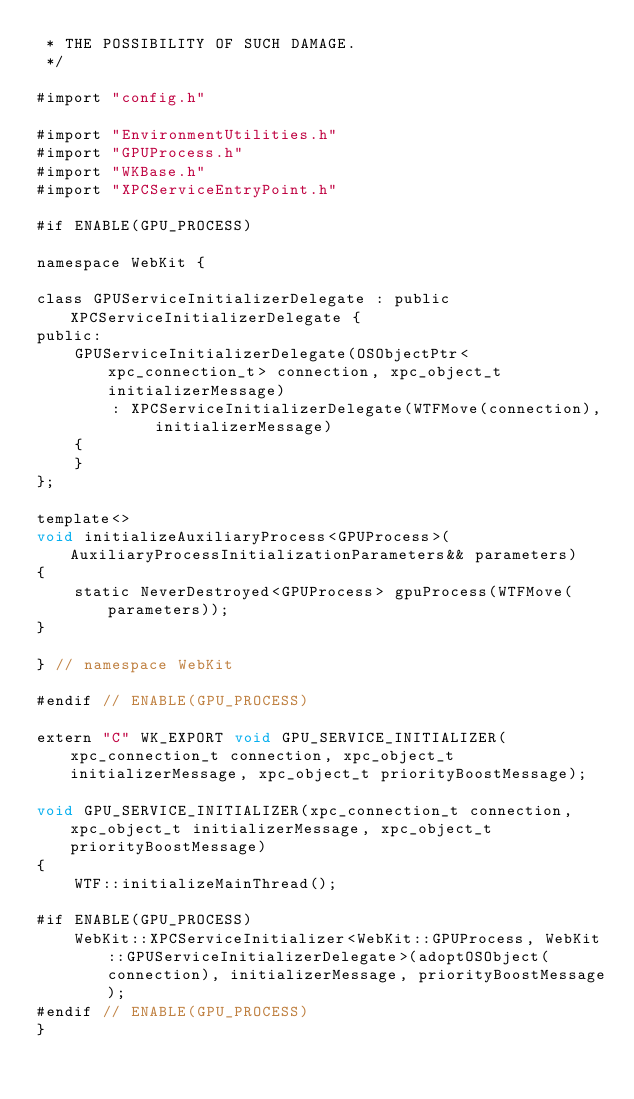<code> <loc_0><loc_0><loc_500><loc_500><_ObjectiveC_> * THE POSSIBILITY OF SUCH DAMAGE.
 */

#import "config.h"

#import "EnvironmentUtilities.h"
#import "GPUProcess.h"
#import "WKBase.h"
#import "XPCServiceEntryPoint.h"

#if ENABLE(GPU_PROCESS)

namespace WebKit {

class GPUServiceInitializerDelegate : public XPCServiceInitializerDelegate {
public:
    GPUServiceInitializerDelegate(OSObjectPtr<xpc_connection_t> connection, xpc_object_t initializerMessage)
        : XPCServiceInitializerDelegate(WTFMove(connection), initializerMessage)
    {
    }
};

template<>
void initializeAuxiliaryProcess<GPUProcess>(AuxiliaryProcessInitializationParameters&& parameters)
{
    static NeverDestroyed<GPUProcess> gpuProcess(WTFMove(parameters));
}

} // namespace WebKit

#endif // ENABLE(GPU_PROCESS)

extern "C" WK_EXPORT void GPU_SERVICE_INITIALIZER(xpc_connection_t connection, xpc_object_t initializerMessage, xpc_object_t priorityBoostMessage);

void GPU_SERVICE_INITIALIZER(xpc_connection_t connection, xpc_object_t initializerMessage, xpc_object_t priorityBoostMessage)
{
    WTF::initializeMainThread();

#if ENABLE(GPU_PROCESS)
    WebKit::XPCServiceInitializer<WebKit::GPUProcess, WebKit::GPUServiceInitializerDelegate>(adoptOSObject(connection), initializerMessage, priorityBoostMessage);
#endif // ENABLE(GPU_PROCESS)
}
</code> 